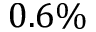<formula> <loc_0><loc_0><loc_500><loc_500>0 . 6 \%</formula> 